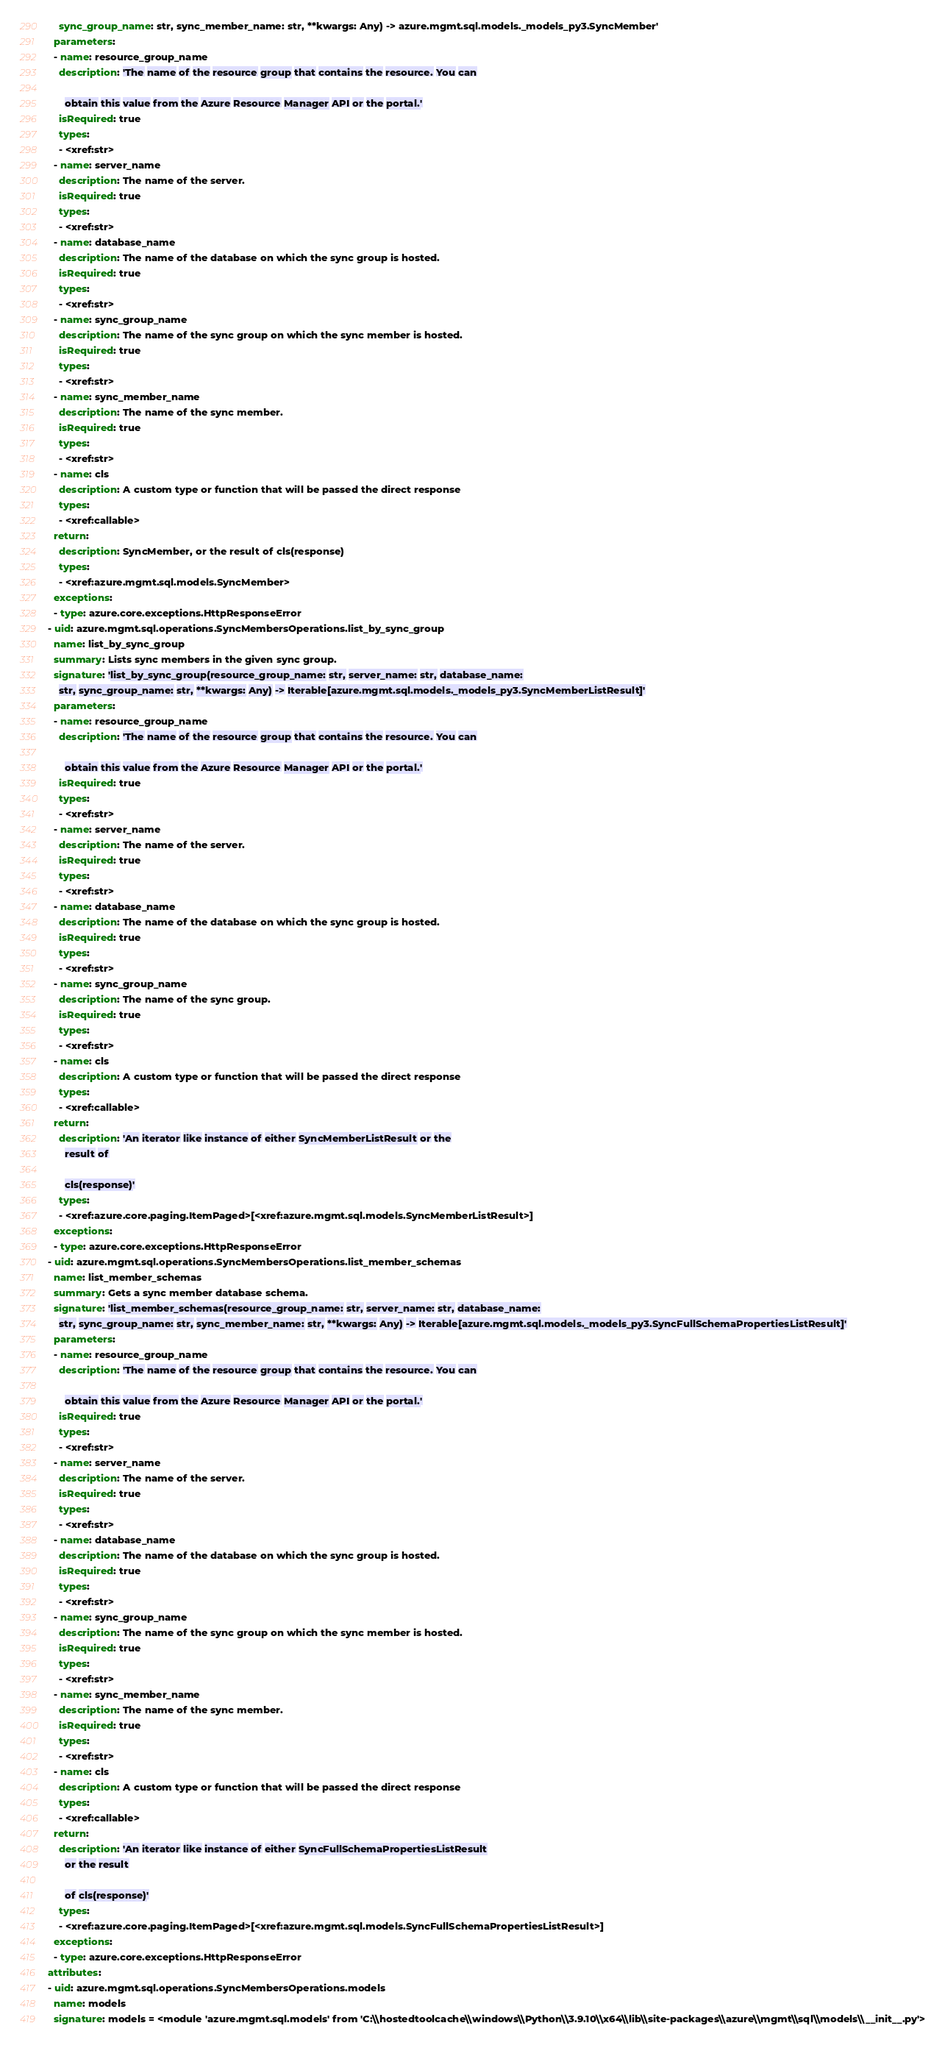Convert code to text. <code><loc_0><loc_0><loc_500><loc_500><_YAML_>    sync_group_name: str, sync_member_name: str, **kwargs: Any) -> azure.mgmt.sql.models._models_py3.SyncMember'
  parameters:
  - name: resource_group_name
    description: 'The name of the resource group that contains the resource. You can

      obtain this value from the Azure Resource Manager API or the portal.'
    isRequired: true
    types:
    - <xref:str>
  - name: server_name
    description: The name of the server.
    isRequired: true
    types:
    - <xref:str>
  - name: database_name
    description: The name of the database on which the sync group is hosted.
    isRequired: true
    types:
    - <xref:str>
  - name: sync_group_name
    description: The name of the sync group on which the sync member is hosted.
    isRequired: true
    types:
    - <xref:str>
  - name: sync_member_name
    description: The name of the sync member.
    isRequired: true
    types:
    - <xref:str>
  - name: cls
    description: A custom type or function that will be passed the direct response
    types:
    - <xref:callable>
  return:
    description: SyncMember, or the result of cls(response)
    types:
    - <xref:azure.mgmt.sql.models.SyncMember>
  exceptions:
  - type: azure.core.exceptions.HttpResponseError
- uid: azure.mgmt.sql.operations.SyncMembersOperations.list_by_sync_group
  name: list_by_sync_group
  summary: Lists sync members in the given sync group.
  signature: 'list_by_sync_group(resource_group_name: str, server_name: str, database_name:
    str, sync_group_name: str, **kwargs: Any) -> Iterable[azure.mgmt.sql.models._models_py3.SyncMemberListResult]'
  parameters:
  - name: resource_group_name
    description: 'The name of the resource group that contains the resource. You can

      obtain this value from the Azure Resource Manager API or the portal.'
    isRequired: true
    types:
    - <xref:str>
  - name: server_name
    description: The name of the server.
    isRequired: true
    types:
    - <xref:str>
  - name: database_name
    description: The name of the database on which the sync group is hosted.
    isRequired: true
    types:
    - <xref:str>
  - name: sync_group_name
    description: The name of the sync group.
    isRequired: true
    types:
    - <xref:str>
  - name: cls
    description: A custom type or function that will be passed the direct response
    types:
    - <xref:callable>
  return:
    description: 'An iterator like instance of either SyncMemberListResult or the
      result of

      cls(response)'
    types:
    - <xref:azure.core.paging.ItemPaged>[<xref:azure.mgmt.sql.models.SyncMemberListResult>]
  exceptions:
  - type: azure.core.exceptions.HttpResponseError
- uid: azure.mgmt.sql.operations.SyncMembersOperations.list_member_schemas
  name: list_member_schemas
  summary: Gets a sync member database schema.
  signature: 'list_member_schemas(resource_group_name: str, server_name: str, database_name:
    str, sync_group_name: str, sync_member_name: str, **kwargs: Any) -> Iterable[azure.mgmt.sql.models._models_py3.SyncFullSchemaPropertiesListResult]'
  parameters:
  - name: resource_group_name
    description: 'The name of the resource group that contains the resource. You can

      obtain this value from the Azure Resource Manager API or the portal.'
    isRequired: true
    types:
    - <xref:str>
  - name: server_name
    description: The name of the server.
    isRequired: true
    types:
    - <xref:str>
  - name: database_name
    description: The name of the database on which the sync group is hosted.
    isRequired: true
    types:
    - <xref:str>
  - name: sync_group_name
    description: The name of the sync group on which the sync member is hosted.
    isRequired: true
    types:
    - <xref:str>
  - name: sync_member_name
    description: The name of the sync member.
    isRequired: true
    types:
    - <xref:str>
  - name: cls
    description: A custom type or function that will be passed the direct response
    types:
    - <xref:callable>
  return:
    description: 'An iterator like instance of either SyncFullSchemaPropertiesListResult
      or the result

      of cls(response)'
    types:
    - <xref:azure.core.paging.ItemPaged>[<xref:azure.mgmt.sql.models.SyncFullSchemaPropertiesListResult>]
  exceptions:
  - type: azure.core.exceptions.HttpResponseError
attributes:
- uid: azure.mgmt.sql.operations.SyncMembersOperations.models
  name: models
  signature: models = <module 'azure.mgmt.sql.models' from 'C:\\hostedtoolcache\\windows\\Python\\3.9.10\\x64\\lib\\site-packages\\azure\\mgmt\\sql\\models\\__init__.py'>
</code> 